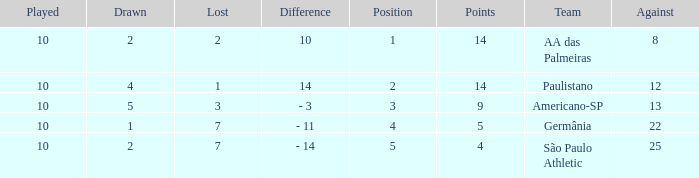What is the lowest Against when the played is more than 10? None. 